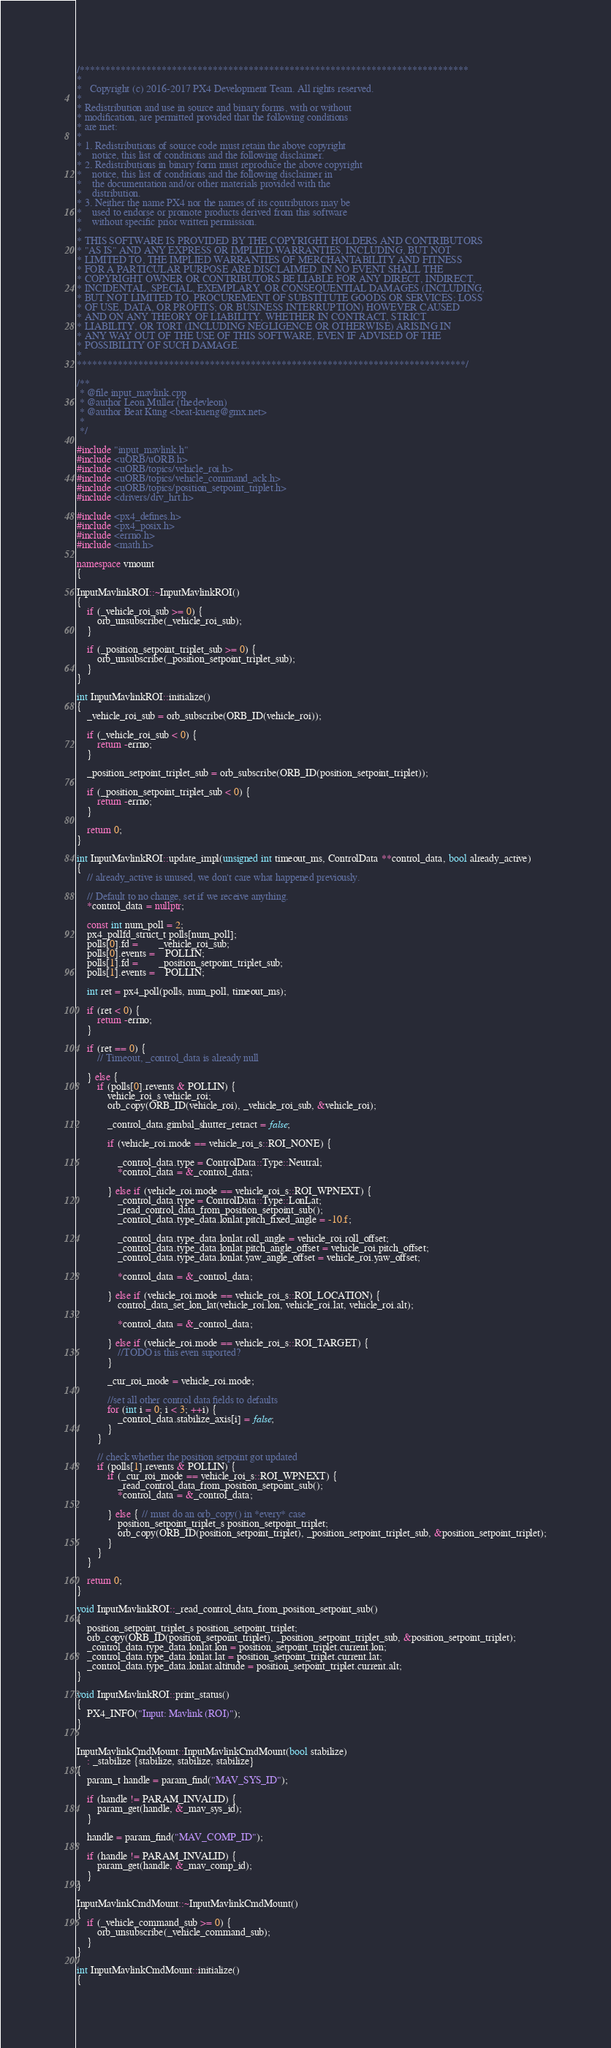Convert code to text. <code><loc_0><loc_0><loc_500><loc_500><_C++_>/****************************************************************************
*
*   Copyright (c) 2016-2017 PX4 Development Team. All rights reserved.
*
* Redistribution and use in source and binary forms, with or without
* modification, are permitted provided that the following conditions
* are met:
*
* 1. Redistributions of source code must retain the above copyright
*    notice, this list of conditions and the following disclaimer.
* 2. Redistributions in binary form must reproduce the above copyright
*    notice, this list of conditions and the following disclaimer in
*    the documentation and/or other materials provided with the
*    distribution.
* 3. Neither the name PX4 nor the names of its contributors may be
*    used to endorse or promote products derived from this software
*    without specific prior written permission.
*
* THIS SOFTWARE IS PROVIDED BY THE COPYRIGHT HOLDERS AND CONTRIBUTORS
* "AS IS" AND ANY EXPRESS OR IMPLIED WARRANTIES, INCLUDING, BUT NOT
* LIMITED TO, THE IMPLIED WARRANTIES OF MERCHANTABILITY AND FITNESS
* FOR A PARTICULAR PURPOSE ARE DISCLAIMED. IN NO EVENT SHALL THE
* COPYRIGHT OWNER OR CONTRIBUTORS BE LIABLE FOR ANY DIRECT, INDIRECT,
* INCIDENTAL, SPECIAL, EXEMPLARY, OR CONSEQUENTIAL DAMAGES (INCLUDING,
* BUT NOT LIMITED TO, PROCUREMENT OF SUBSTITUTE GOODS OR SERVICES; LOSS
* OF USE, DATA, OR PROFITS; OR BUSINESS INTERRUPTION) HOWEVER CAUSED
* AND ON ANY THEORY OF LIABILITY, WHETHER IN CONTRACT, STRICT
* LIABILITY, OR TORT (INCLUDING NEGLIGENCE OR OTHERWISE) ARISING IN
* ANY WAY OUT OF THE USE OF THIS SOFTWARE, EVEN IF ADVISED OF THE
* POSSIBILITY OF SUCH DAMAGE.
*
****************************************************************************/

/**
 * @file input_mavlink.cpp
 * @author Leon Müller (thedevleon)
 * @author Beat Küng <beat-kueng@gmx.net>
 *
 */

#include "input_mavlink.h"
#include <uORB/uORB.h>
#include <uORB/topics/vehicle_roi.h>
#include <uORB/topics/vehicle_command_ack.h>
#include <uORB/topics/position_setpoint_triplet.h>
#include <drivers/drv_hrt.h>

#include <px4_defines.h>
#include <px4_posix.h>
#include <errno.h>
#include <math.h>

namespace vmount
{

InputMavlinkROI::~InputMavlinkROI()
{
	if (_vehicle_roi_sub >= 0) {
		orb_unsubscribe(_vehicle_roi_sub);
	}

	if (_position_setpoint_triplet_sub >= 0) {
		orb_unsubscribe(_position_setpoint_triplet_sub);
	}
}

int InputMavlinkROI::initialize()
{
	_vehicle_roi_sub = orb_subscribe(ORB_ID(vehicle_roi));

	if (_vehicle_roi_sub < 0) {
		return -errno;
	}

	_position_setpoint_triplet_sub = orb_subscribe(ORB_ID(position_setpoint_triplet));

	if (_position_setpoint_triplet_sub < 0) {
		return -errno;
	}

	return 0;
}

int InputMavlinkROI::update_impl(unsigned int timeout_ms, ControlData **control_data, bool already_active)
{
	// already_active is unused, we don't care what happened previously.

	// Default to no change, set if we receive anything.
	*control_data = nullptr;

	const int num_poll = 2;
	px4_pollfd_struct_t polls[num_poll];
	polls[0].fd = 		_vehicle_roi_sub;
	polls[0].events = 	POLLIN;
	polls[1].fd = 		_position_setpoint_triplet_sub;
	polls[1].events = 	POLLIN;

	int ret = px4_poll(polls, num_poll, timeout_ms);

	if (ret < 0) {
		return -errno;
	}

	if (ret == 0) {
		// Timeout, _control_data is already null

	} else {
		if (polls[0].revents & POLLIN) {
			vehicle_roi_s vehicle_roi;
			orb_copy(ORB_ID(vehicle_roi), _vehicle_roi_sub, &vehicle_roi);

			_control_data.gimbal_shutter_retract = false;

			if (vehicle_roi.mode == vehicle_roi_s::ROI_NONE) {

				_control_data.type = ControlData::Type::Neutral;
				*control_data = &_control_data;

			} else if (vehicle_roi.mode == vehicle_roi_s::ROI_WPNEXT) {
				_control_data.type = ControlData::Type::LonLat;
				_read_control_data_from_position_setpoint_sub();
				_control_data.type_data.lonlat.pitch_fixed_angle = -10.f;

				_control_data.type_data.lonlat.roll_angle = vehicle_roi.roll_offset;
				_control_data.type_data.lonlat.pitch_angle_offset = vehicle_roi.pitch_offset;
				_control_data.type_data.lonlat.yaw_angle_offset = vehicle_roi.yaw_offset;

				*control_data = &_control_data;

			} else if (vehicle_roi.mode == vehicle_roi_s::ROI_LOCATION) {
				control_data_set_lon_lat(vehicle_roi.lon, vehicle_roi.lat, vehicle_roi.alt);

				*control_data = &_control_data;

			} else if (vehicle_roi.mode == vehicle_roi_s::ROI_TARGET) {
				//TODO is this even suported?
			}

			_cur_roi_mode = vehicle_roi.mode;

			//set all other control data fields to defaults
			for (int i = 0; i < 3; ++i) {
				_control_data.stabilize_axis[i] = false;
			}
		}

		// check whether the position setpoint got updated
		if (polls[1].revents & POLLIN) {
			if (_cur_roi_mode == vehicle_roi_s::ROI_WPNEXT) {
				_read_control_data_from_position_setpoint_sub();
				*control_data = &_control_data;

			} else { // must do an orb_copy() in *every* case
				position_setpoint_triplet_s position_setpoint_triplet;
				orb_copy(ORB_ID(position_setpoint_triplet), _position_setpoint_triplet_sub, &position_setpoint_triplet);
			}
		}
	}

	return 0;
}

void InputMavlinkROI::_read_control_data_from_position_setpoint_sub()
{
	position_setpoint_triplet_s position_setpoint_triplet;
	orb_copy(ORB_ID(position_setpoint_triplet), _position_setpoint_triplet_sub, &position_setpoint_triplet);
	_control_data.type_data.lonlat.lon = position_setpoint_triplet.current.lon;
	_control_data.type_data.lonlat.lat = position_setpoint_triplet.current.lat;
	_control_data.type_data.lonlat.altitude = position_setpoint_triplet.current.alt;
}

void InputMavlinkROI::print_status()
{
	PX4_INFO("Input: Mavlink (ROI)");
}


InputMavlinkCmdMount::InputMavlinkCmdMount(bool stabilize)
	: _stabilize {stabilize, stabilize, stabilize}
{
	param_t handle = param_find("MAV_SYS_ID");

	if (handle != PARAM_INVALID) {
		param_get(handle, &_mav_sys_id);
	}

	handle = param_find("MAV_COMP_ID");

	if (handle != PARAM_INVALID) {
		param_get(handle, &_mav_comp_id);
	}
}

InputMavlinkCmdMount::~InputMavlinkCmdMount()
{
	if (_vehicle_command_sub >= 0) {
		orb_unsubscribe(_vehicle_command_sub);
	}
}

int InputMavlinkCmdMount::initialize()
{</code> 